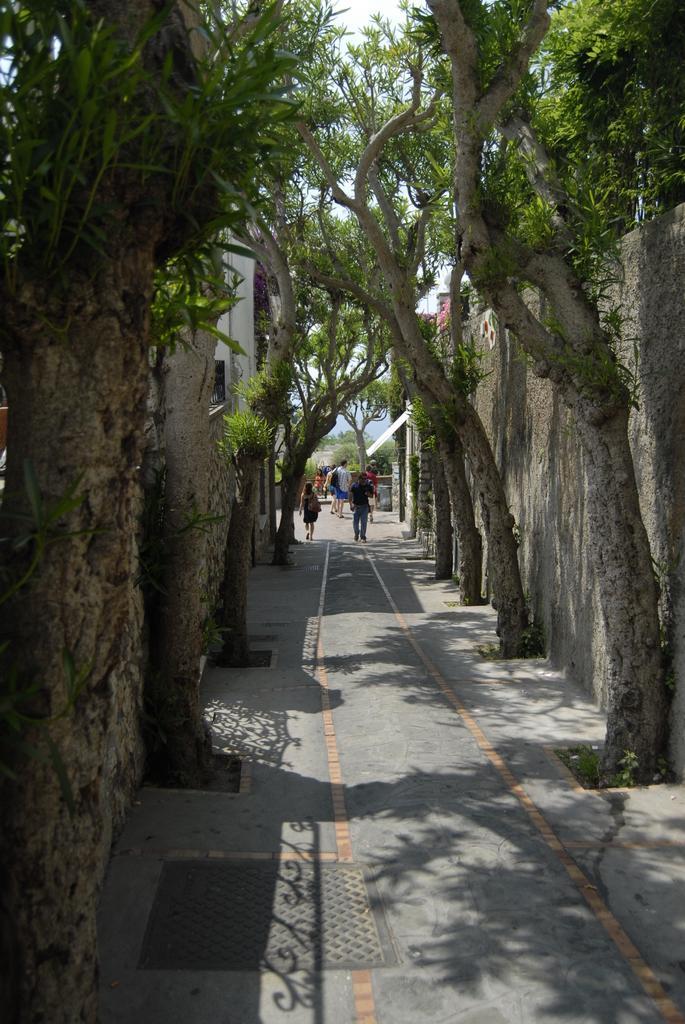In one or two sentences, can you explain what this image depicts? In the center of the image we can see persons on the road. On the right and left side of the image we can see buildings, wall and trees. In the background we can see trees and sky. 